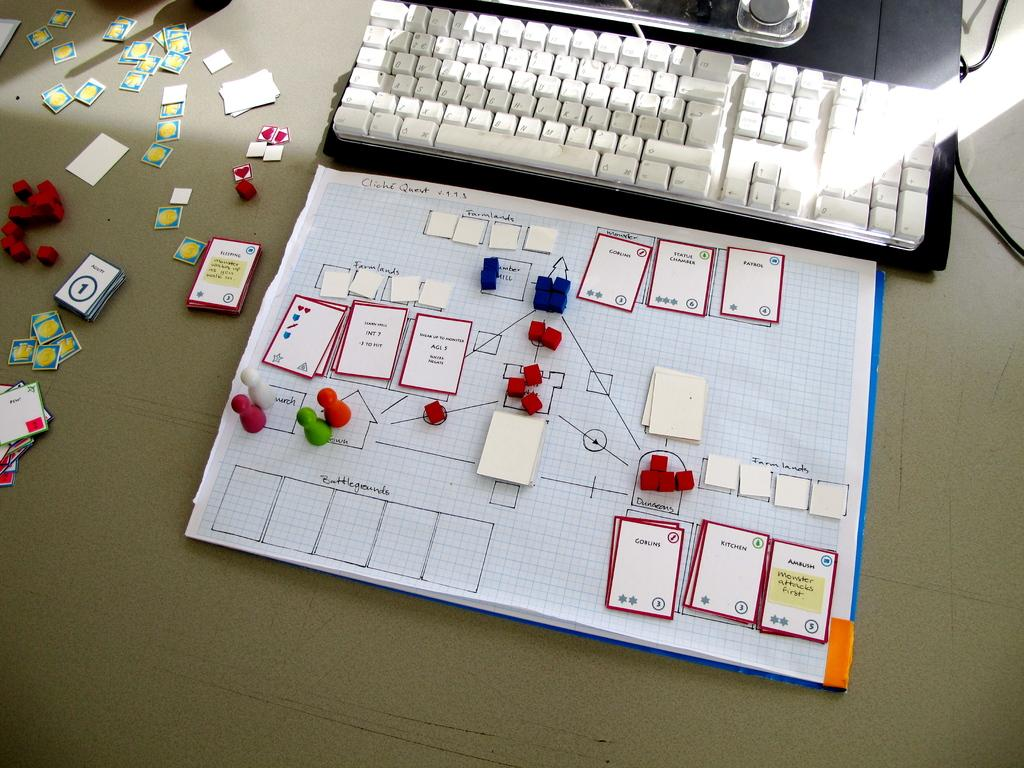Provide a one-sentence caption for the provided image. A chart that has several cards including one that says Kitchen. 